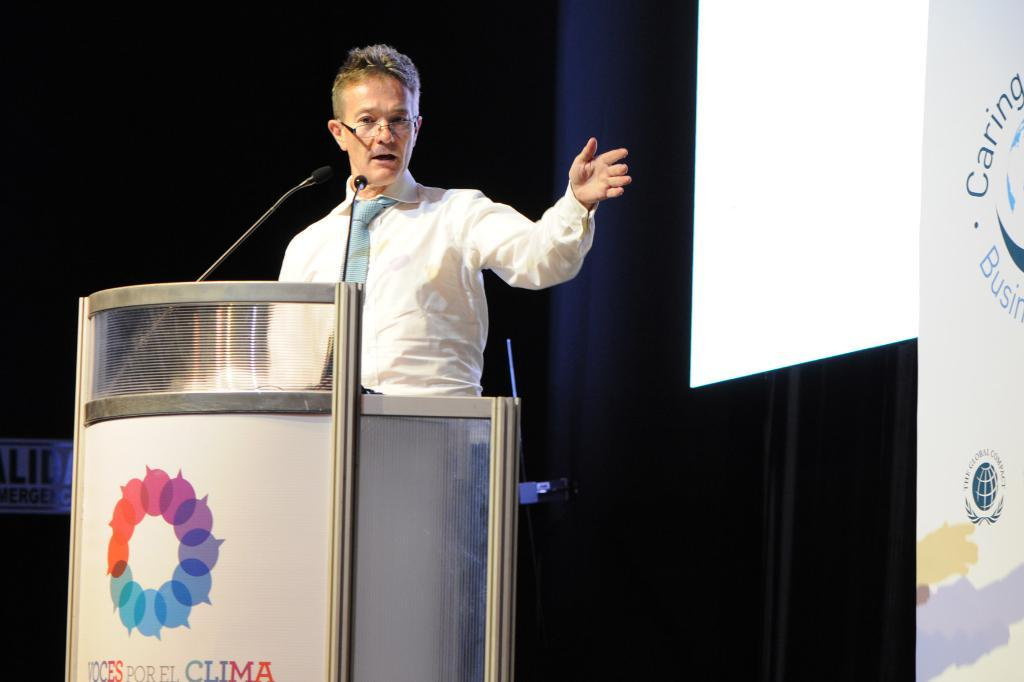Provide a one-sentence caption for the provided image. a man standing at a podium reading Por El Clima. 